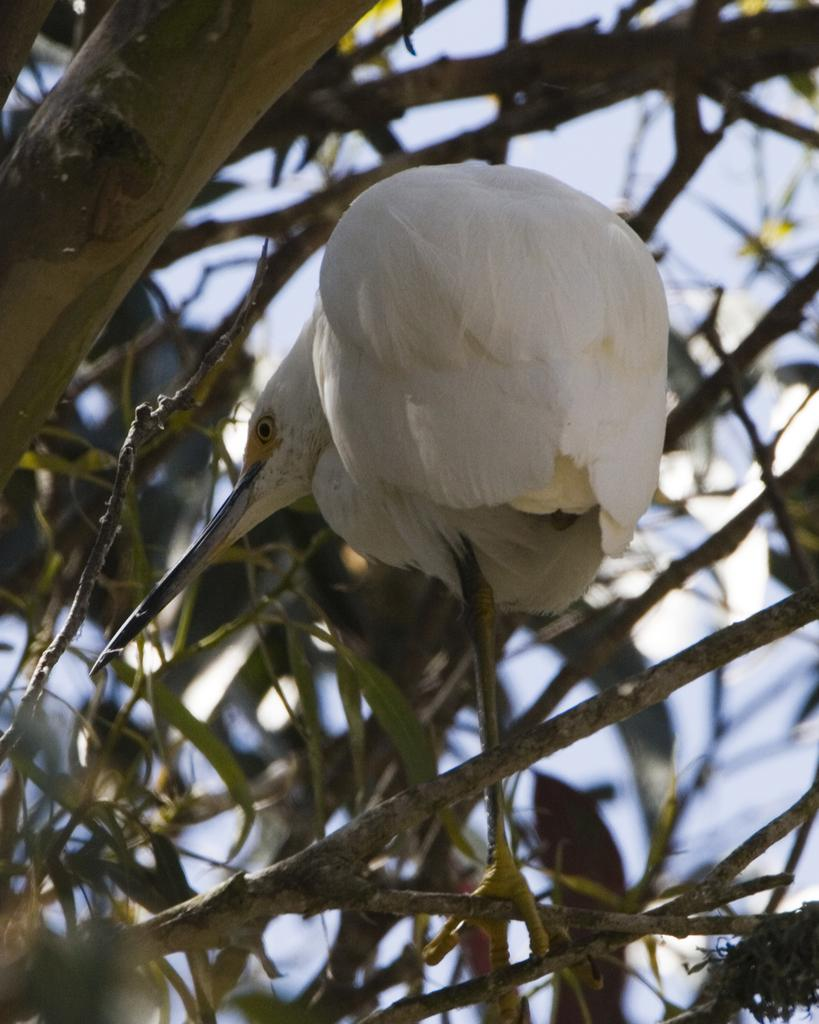What is the main subject in the front of the image? There is a bird in the front of the image. What can be seen in the image besides the bird? There are branches and leaves in the image. What is visible through the branches? The sky is visible through the branches. What type of quartz can be seen on the bird's head in the image? There is no quartz present on the bird's head in the image. Can you tell me how many trains are visible in the image? There are no trains visible in the image. 